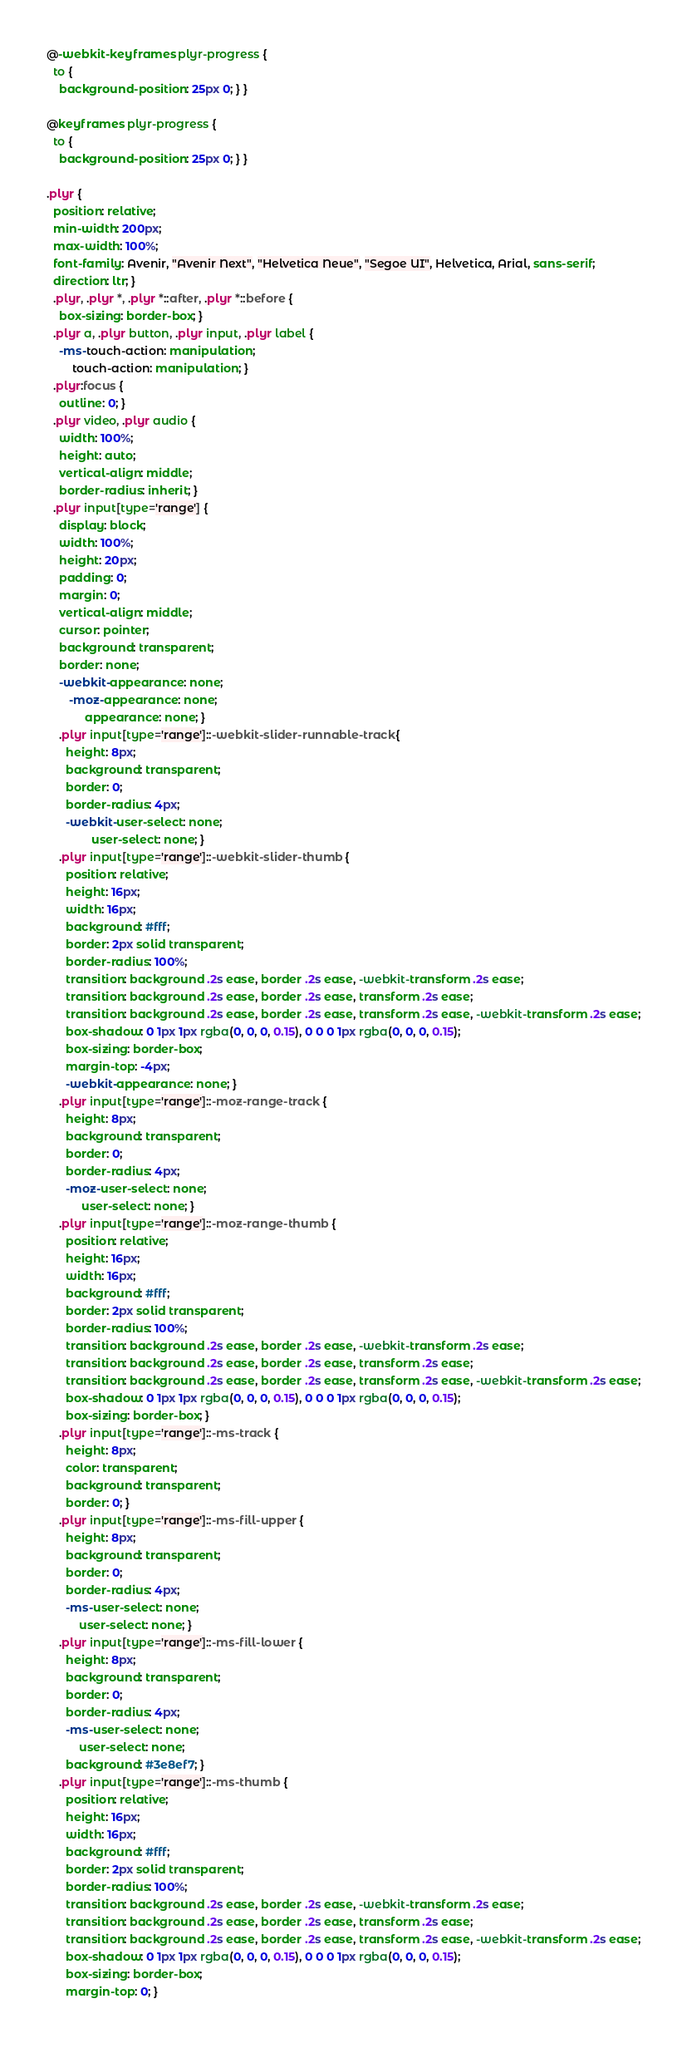Convert code to text. <code><loc_0><loc_0><loc_500><loc_500><_CSS_>@-webkit-keyframes plyr-progress {
  to {
    background-position: 25px 0; } }

@keyframes plyr-progress {
  to {
    background-position: 25px 0; } }

.plyr {
  position: relative;
  min-width: 200px;
  max-width: 100%;
  font-family: Avenir, "Avenir Next", "Helvetica Neue", "Segoe UI", Helvetica, Arial, sans-serif;
  direction: ltr; }
  .plyr, .plyr *, .plyr *::after, .plyr *::before {
    box-sizing: border-box; }
  .plyr a, .plyr button, .plyr input, .plyr label {
    -ms-touch-action: manipulation;
        touch-action: manipulation; }
  .plyr:focus {
    outline: 0; }
  .plyr video, .plyr audio {
    width: 100%;
    height: auto;
    vertical-align: middle;
    border-radius: inherit; }
  .plyr input[type='range'] {
    display: block;
    width: 100%;
    height: 20px;
    padding: 0;
    margin: 0;
    vertical-align: middle;
    cursor: pointer;
    background: transparent;
    border: none;
    -webkit-appearance: none;
       -moz-appearance: none;
            appearance: none; }
    .plyr input[type='range']::-webkit-slider-runnable-track {
      height: 8px;
      background: transparent;
      border: 0;
      border-radius: 4px;
      -webkit-user-select: none;
              user-select: none; }
    .plyr input[type='range']::-webkit-slider-thumb {
      position: relative;
      height: 16px;
      width: 16px;
      background: #fff;
      border: 2px solid transparent;
      border-radius: 100%;
      transition: background .2s ease, border .2s ease, -webkit-transform .2s ease;
      transition: background .2s ease, border .2s ease, transform .2s ease;
      transition: background .2s ease, border .2s ease, transform .2s ease, -webkit-transform .2s ease;
      box-shadow: 0 1px 1px rgba(0, 0, 0, 0.15), 0 0 0 1px rgba(0, 0, 0, 0.15);
      box-sizing: border-box;
      margin-top: -4px;
      -webkit-appearance: none; }
    .plyr input[type='range']::-moz-range-track {
      height: 8px;
      background: transparent;
      border: 0;
      border-radius: 4px;
      -moz-user-select: none;
           user-select: none; }
    .plyr input[type='range']::-moz-range-thumb {
      position: relative;
      height: 16px;
      width: 16px;
      background: #fff;
      border: 2px solid transparent;
      border-radius: 100%;
      transition: background .2s ease, border .2s ease, -webkit-transform .2s ease;
      transition: background .2s ease, border .2s ease, transform .2s ease;
      transition: background .2s ease, border .2s ease, transform .2s ease, -webkit-transform .2s ease;
      box-shadow: 0 1px 1px rgba(0, 0, 0, 0.15), 0 0 0 1px rgba(0, 0, 0, 0.15);
      box-sizing: border-box; }
    .plyr input[type='range']::-ms-track {
      height: 8px;
      color: transparent;
      background: transparent;
      border: 0; }
    .plyr input[type='range']::-ms-fill-upper {
      height: 8px;
      background: transparent;
      border: 0;
      border-radius: 4px;
      -ms-user-select: none;
          user-select: none; }
    .plyr input[type='range']::-ms-fill-lower {
      height: 8px;
      background: transparent;
      border: 0;
      border-radius: 4px;
      -ms-user-select: none;
          user-select: none;
      background: #3e8ef7; }
    .plyr input[type='range']::-ms-thumb {
      position: relative;
      height: 16px;
      width: 16px;
      background: #fff;
      border: 2px solid transparent;
      border-radius: 100%;
      transition: background .2s ease, border .2s ease, -webkit-transform .2s ease;
      transition: background .2s ease, border .2s ease, transform .2s ease;
      transition: background .2s ease, border .2s ease, transform .2s ease, -webkit-transform .2s ease;
      box-shadow: 0 1px 1px rgba(0, 0, 0, 0.15), 0 0 0 1px rgba(0, 0, 0, 0.15);
      box-sizing: border-box;
      margin-top: 0; }</code> 